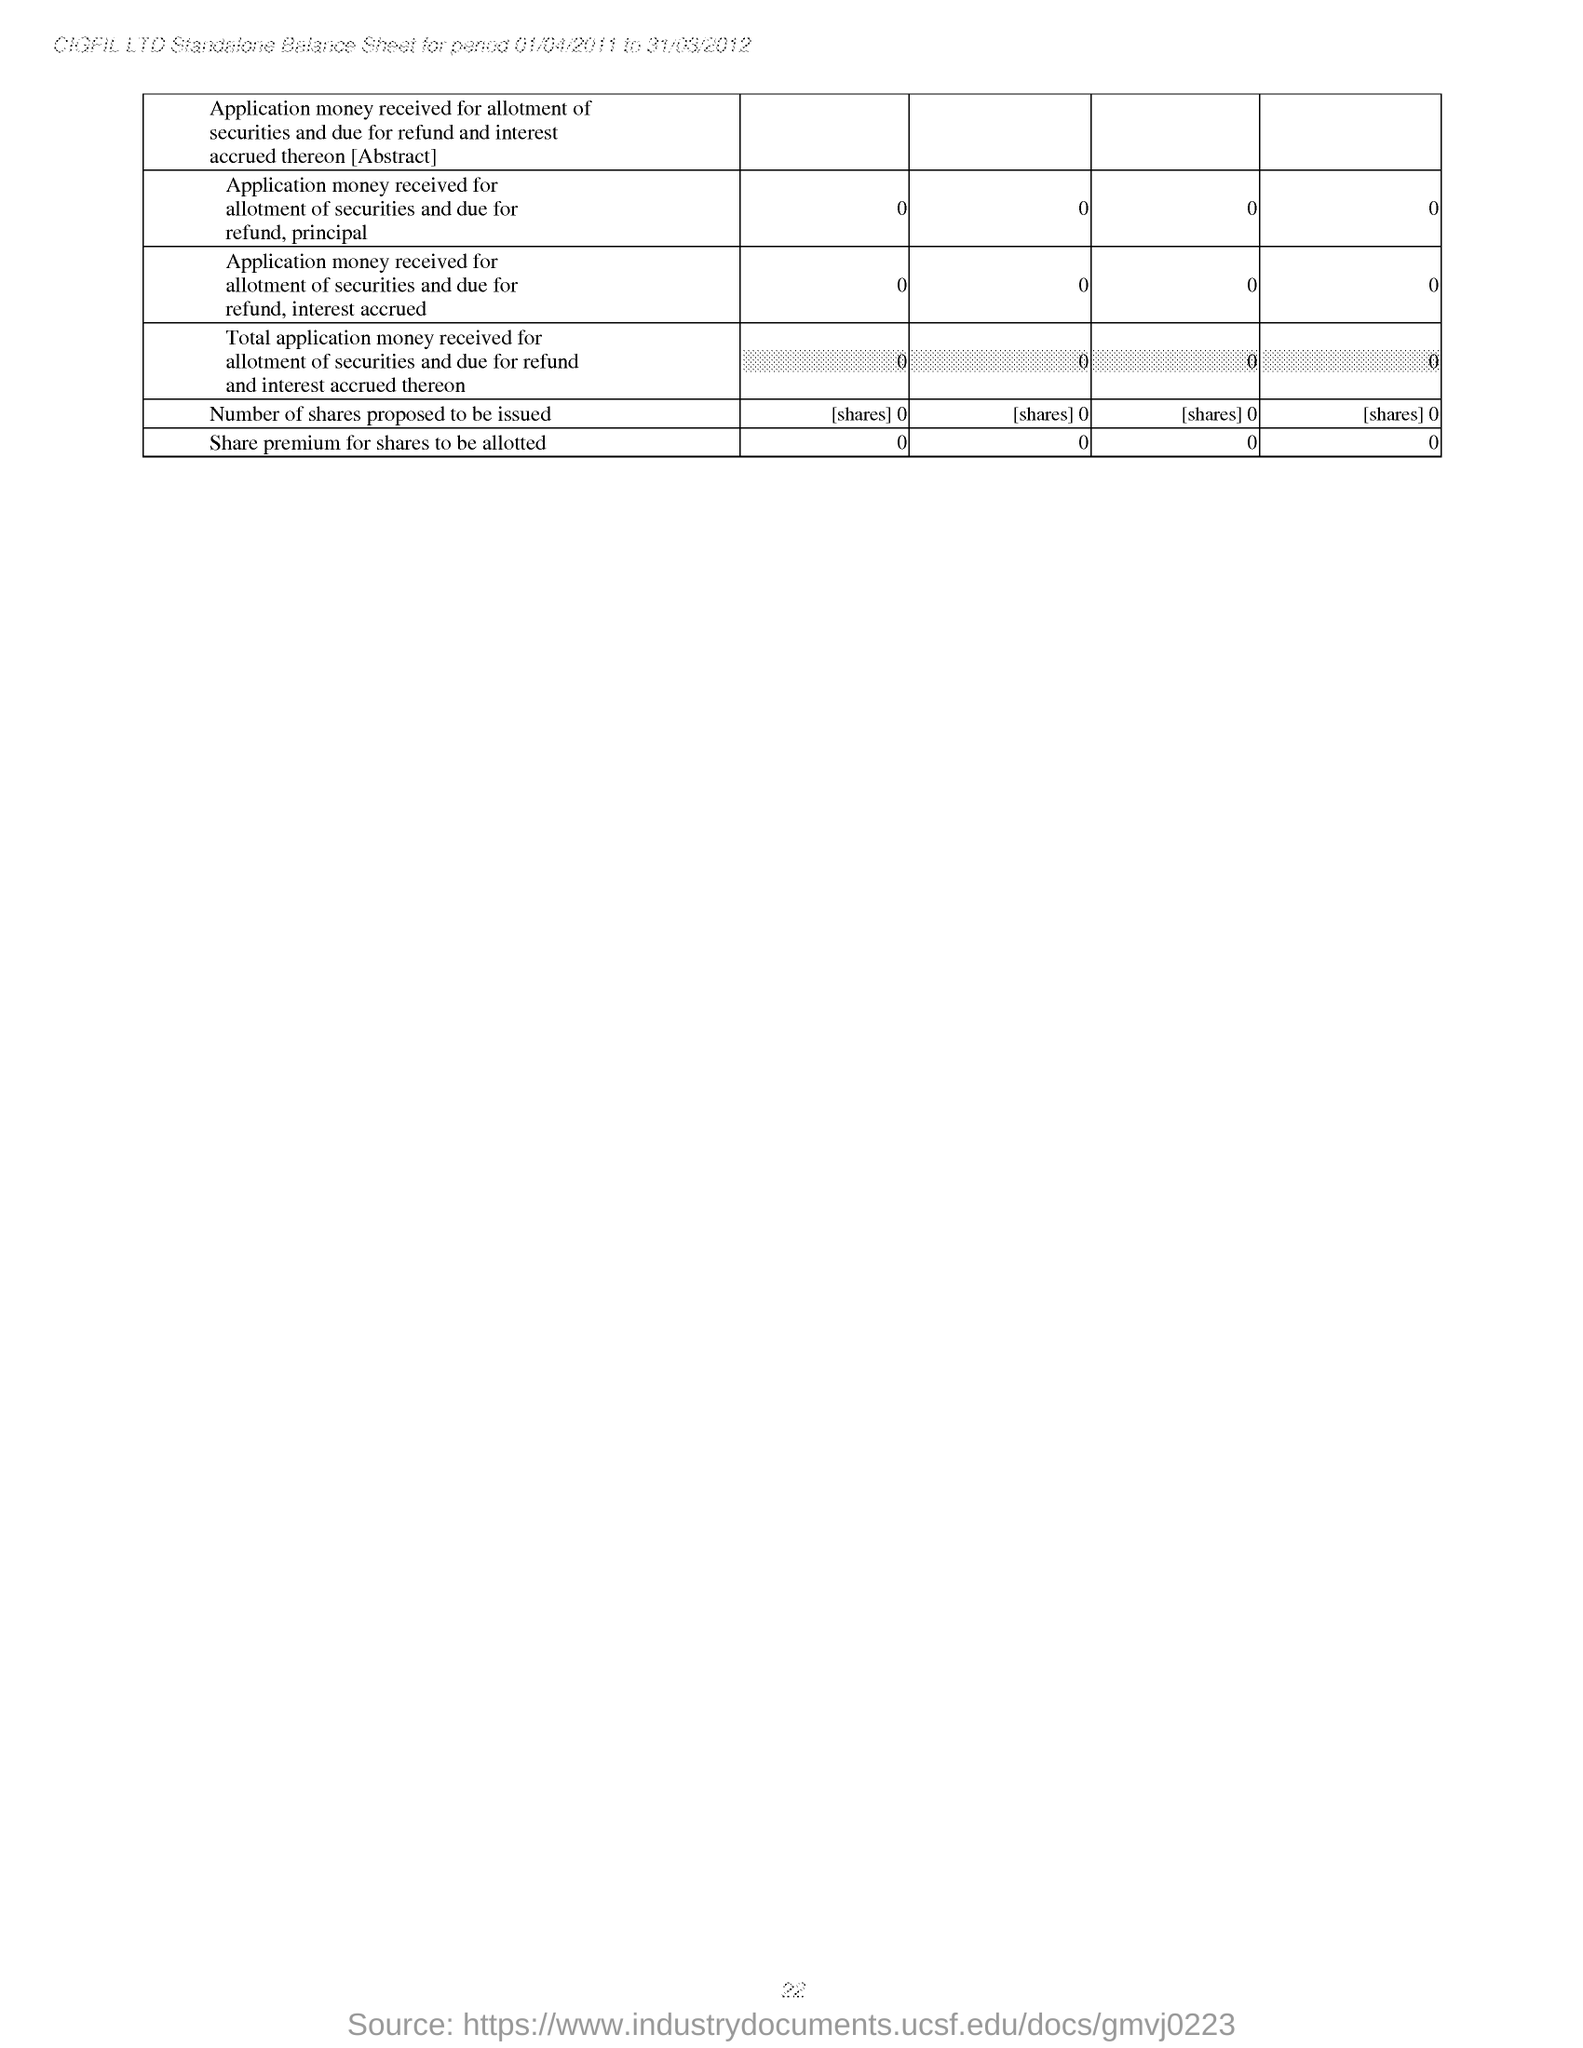What is the company name specified in the header of the document?
Give a very brief answer. CIGFIL LTD. Which period's Standalone Balance sheet is mentioned in the header of the document?
Provide a short and direct response. 01/04/2011 to 31/03/2012. 